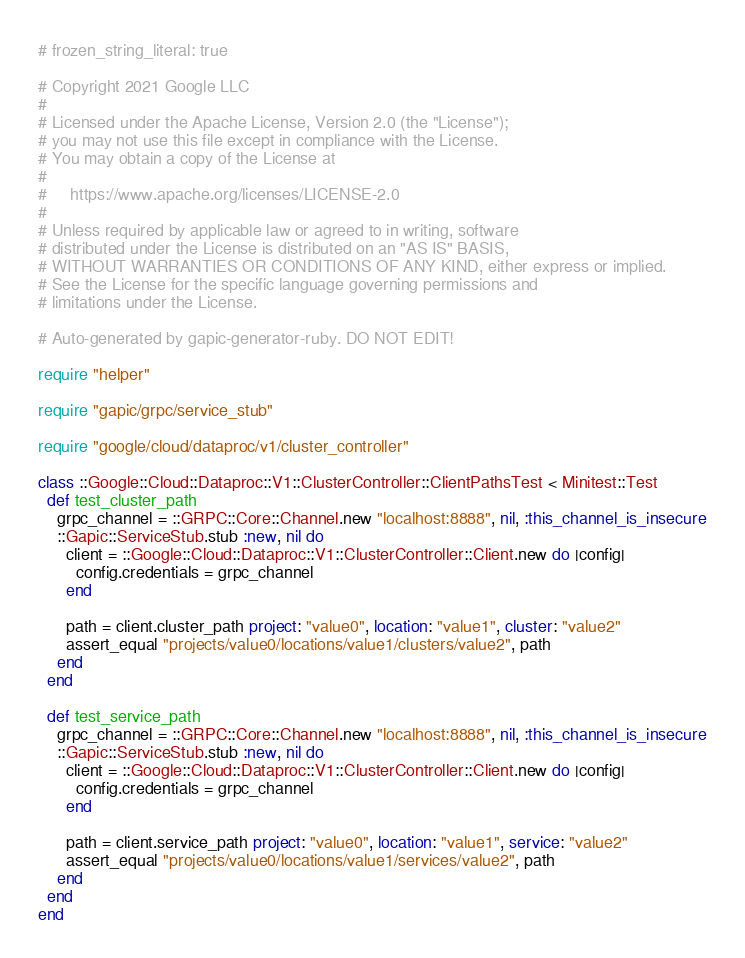Convert code to text. <code><loc_0><loc_0><loc_500><loc_500><_Ruby_># frozen_string_literal: true

# Copyright 2021 Google LLC
#
# Licensed under the Apache License, Version 2.0 (the "License");
# you may not use this file except in compliance with the License.
# You may obtain a copy of the License at
#
#     https://www.apache.org/licenses/LICENSE-2.0
#
# Unless required by applicable law or agreed to in writing, software
# distributed under the License is distributed on an "AS IS" BASIS,
# WITHOUT WARRANTIES OR CONDITIONS OF ANY KIND, either express or implied.
# See the License for the specific language governing permissions and
# limitations under the License.

# Auto-generated by gapic-generator-ruby. DO NOT EDIT!

require "helper"

require "gapic/grpc/service_stub"

require "google/cloud/dataproc/v1/cluster_controller"

class ::Google::Cloud::Dataproc::V1::ClusterController::ClientPathsTest < Minitest::Test
  def test_cluster_path
    grpc_channel = ::GRPC::Core::Channel.new "localhost:8888", nil, :this_channel_is_insecure
    ::Gapic::ServiceStub.stub :new, nil do
      client = ::Google::Cloud::Dataproc::V1::ClusterController::Client.new do |config|
        config.credentials = grpc_channel
      end

      path = client.cluster_path project: "value0", location: "value1", cluster: "value2"
      assert_equal "projects/value0/locations/value1/clusters/value2", path
    end
  end

  def test_service_path
    grpc_channel = ::GRPC::Core::Channel.new "localhost:8888", nil, :this_channel_is_insecure
    ::Gapic::ServiceStub.stub :new, nil do
      client = ::Google::Cloud::Dataproc::V1::ClusterController::Client.new do |config|
        config.credentials = grpc_channel
      end

      path = client.service_path project: "value0", location: "value1", service: "value2"
      assert_equal "projects/value0/locations/value1/services/value2", path
    end
  end
end
</code> 